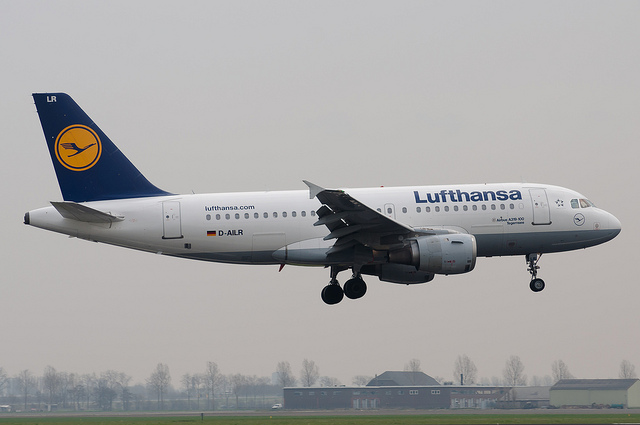Please extract the text content from this image. LR lufthansa.com AULR Lufthansa 